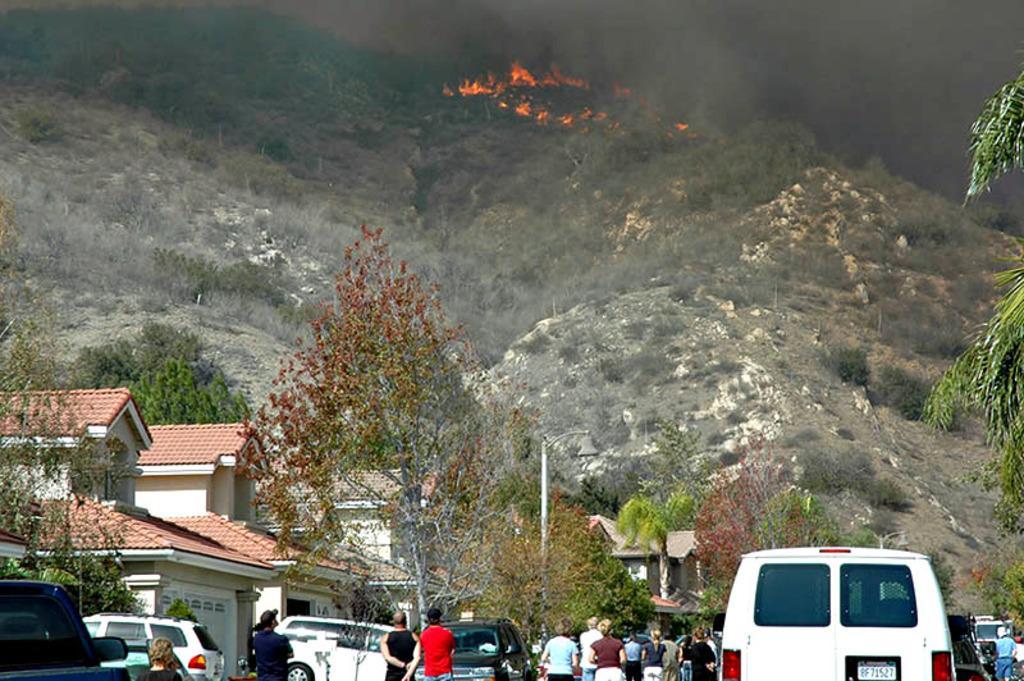Describe this image in one or two sentences. As we can see fire caught in the forest and many people are seeing that fire 